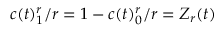<formula> <loc_0><loc_0><loc_500><loc_500>c ( t ) _ { 1 } ^ { r } / r = 1 - c ( t ) _ { 0 } ^ { r } / r = Z _ { r } ( t )</formula> 